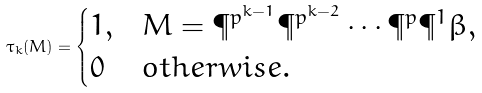Convert formula to latex. <formula><loc_0><loc_0><loc_500><loc_500>\tau _ { k } ( M ) = \begin{cases} 1 , & M = \P ^ { p ^ { k - 1 } } \P ^ { p ^ { k - 2 } } \cdots \P ^ { p } \P ^ { 1 } \beta , \\ 0 & o t h e r w i s e . \end{cases}</formula> 